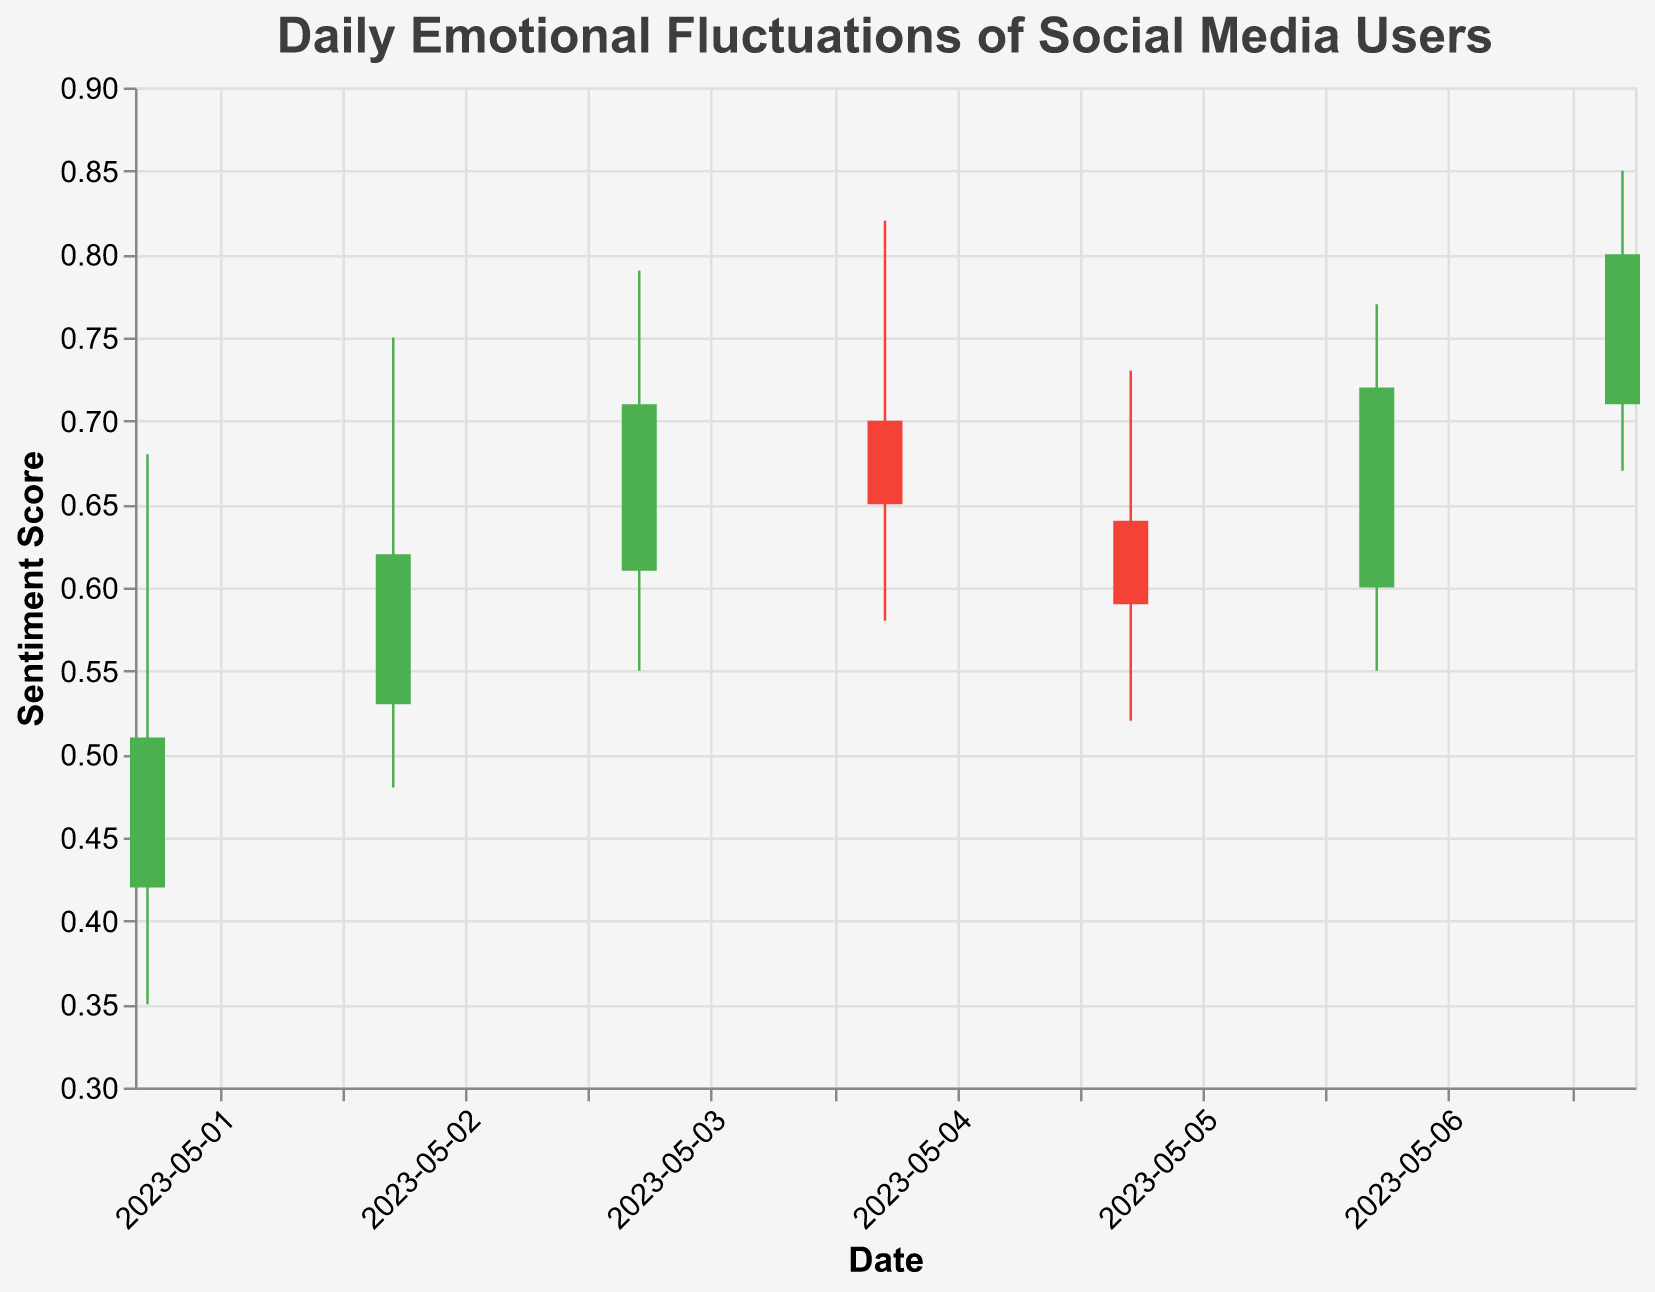What's the title of the chart? The title is displayed at the top of the figure. It's "Daily Emotional Fluctuations of Social Media Users".
Answer: Daily Emotional Fluctuations of Social Media Users What does the y-axis represent? The label on the y-axis indicates it measures the "Sentiment Score".
Answer: Sentiment Score How many days of data are presented in the chart? By counting the number of different dates on the x-axis, you can see that data spanning seven days is shown.
Answer: Seven days Which day had the highest sentiment score? Looking at the high points of each day, May 7th had the highest sentiment score of 0.85.
Answer: May 7th On which day did users' sentiment score close lower than it opened? Observe the color and bar shapes. Bars in red indicate the Close value is lower than the Open value. May 5th is the day where this happens.
Answer: May 5th What was the lowest sentiment score recorded and on which date? By identifying the lowest "Low" value in the data, the lowest sentiment score of 0.35 occurred on May 1st.
Answer: 0.35 on May 1st Which day had the smallest range of sentiment scores from low to high? Calculate the range (High - Low) for each day. May 5th has the smallest range with High 0.73 and Low 0.52, making the range 0.21.
Answer: May 5th How many days had a positive close relative to the open? Count the number of days with green bars, indicating the Close value is higher than the Open value. This happens on May 1st, May 2nd, May 3rd, May 6th, and May 7th.
Answer: Five days Is there a trend in the daily sentiment scores? Review the sequence in the closing values: initially upward, dipping on May 4th and 5th, then rising again on May 6th and 7th. This indicates an overall fluctuation with an upward trend towards the end.
Answer: Fluctuating with an upward trend Comparing the opening and closing values, which day shows the biggest positive change? Calculate the differences (Close - Open) for each day and find the largest. May 7th has the largest positive difference (0.80 - 0.71 = 0.09).
Answer: May 7th 